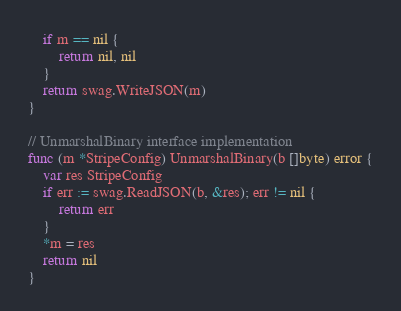Convert code to text. <code><loc_0><loc_0><loc_500><loc_500><_Go_>	if m == nil {
		return nil, nil
	}
	return swag.WriteJSON(m)
}

// UnmarshalBinary interface implementation
func (m *StripeConfig) UnmarshalBinary(b []byte) error {
	var res StripeConfig
	if err := swag.ReadJSON(b, &res); err != nil {
		return err
	}
	*m = res
	return nil
}
</code> 